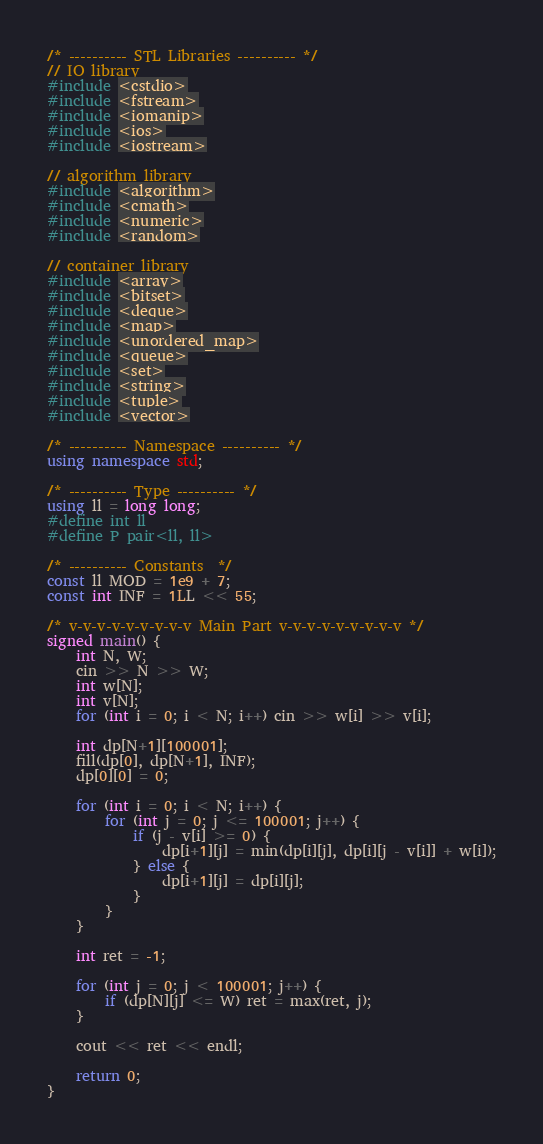<code> <loc_0><loc_0><loc_500><loc_500><_C++_>/* ---------- STL Libraries ---------- */
// IO library
#include <cstdio>
#include <fstream>
#include <iomanip>
#include <ios>
#include <iostream>

// algorithm library
#include <algorithm>
#include <cmath>
#include <numeric>
#include <random>

// container library
#include <array>
#include <bitset>
#include <deque>
#include <map>
#include <unordered_map>
#include <queue>
#include <set>
#include <string>
#include <tuple>
#include <vector>

/* ---------- Namespace ---------- */
using namespace std;

/* ---------- Type ---------- */
using ll = long long;
#define int ll
#define P pair<ll, ll>

/* ---------- Constants  */
const ll MOD = 1e9 + 7;
const int INF = 1LL << 55;

/* v-v-v-v-v-v-v-v-v Main Part v-v-v-v-v-v-v-v-v */
signed main() {
    int N, W;
    cin >> N >> W;
    int w[N];
    int v[N];
    for (int i = 0; i < N; i++) cin >> w[i] >> v[i];

    int dp[N+1][100001];
    fill(dp[0], dp[N+1], INF);
    dp[0][0] = 0;

    for (int i = 0; i < N; i++) {
        for (int j = 0; j <= 100001; j++) {
            if (j - v[i] >= 0) {
                dp[i+1][j] = min(dp[i][j], dp[i][j - v[i]] + w[i]);
            } else {
                dp[i+1][j] = dp[i][j];
            }
        }
    }

    int ret = -1;

    for (int j = 0; j < 100001; j++) {
        if (dp[N][j] <= W) ret = max(ret, j);
    }

    cout << ret << endl;

    return 0;
}</code> 